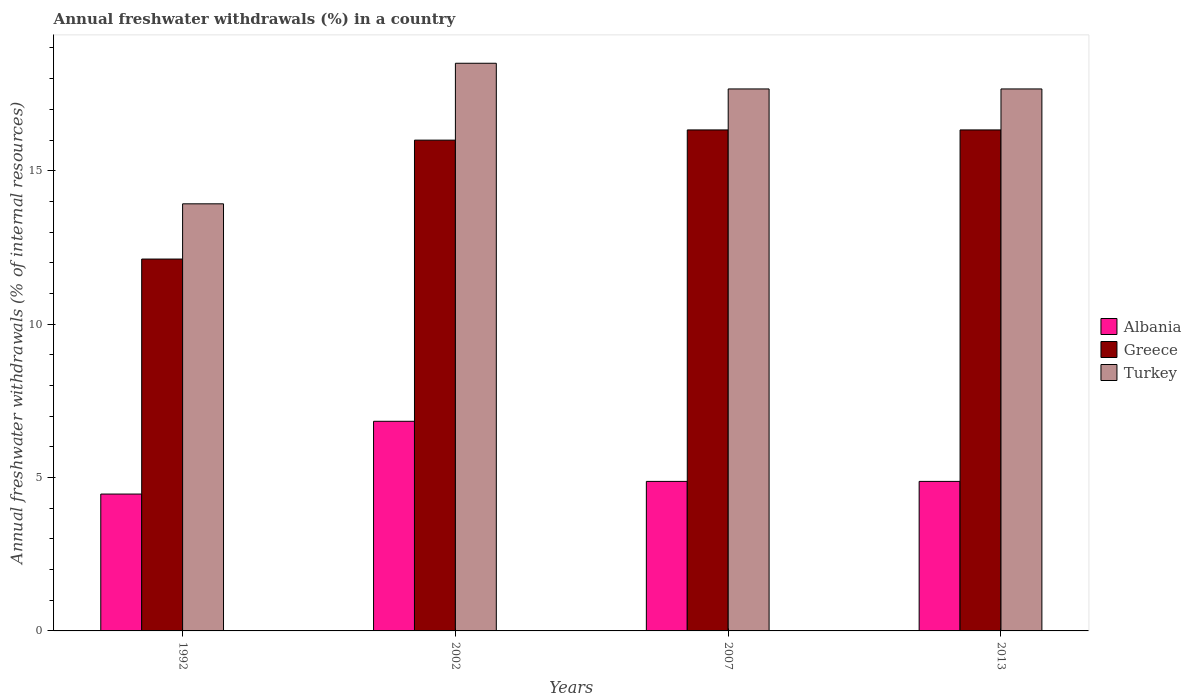How many different coloured bars are there?
Your response must be concise. 3. Are the number of bars per tick equal to the number of legend labels?
Your answer should be very brief. Yes. Are the number of bars on each tick of the X-axis equal?
Provide a succinct answer. Yes. How many bars are there on the 2nd tick from the right?
Offer a terse response. 3. What is the label of the 4th group of bars from the left?
Your response must be concise. 2013. In how many cases, is the number of bars for a given year not equal to the number of legend labels?
Give a very brief answer. 0. What is the percentage of annual freshwater withdrawals in Greece in 2002?
Keep it short and to the point. 16. Across all years, what is the maximum percentage of annual freshwater withdrawals in Albania?
Ensure brevity in your answer.  6.83. Across all years, what is the minimum percentage of annual freshwater withdrawals in Greece?
Give a very brief answer. 12.12. In which year was the percentage of annual freshwater withdrawals in Turkey maximum?
Your answer should be very brief. 2002. What is the total percentage of annual freshwater withdrawals in Greece in the graph?
Ensure brevity in your answer.  60.78. What is the difference between the percentage of annual freshwater withdrawals in Albania in 2002 and that in 2013?
Your answer should be compact. 1.96. What is the difference between the percentage of annual freshwater withdrawals in Albania in 2007 and the percentage of annual freshwater withdrawals in Greece in 2002?
Ensure brevity in your answer.  -11.12. What is the average percentage of annual freshwater withdrawals in Albania per year?
Give a very brief answer. 5.26. In the year 1992, what is the difference between the percentage of annual freshwater withdrawals in Greece and percentage of annual freshwater withdrawals in Turkey?
Offer a very short reply. -1.8. In how many years, is the percentage of annual freshwater withdrawals in Albania greater than 7 %?
Ensure brevity in your answer.  0. What is the ratio of the percentage of annual freshwater withdrawals in Albania in 1992 to that in 2007?
Provide a short and direct response. 0.92. Is the percentage of annual freshwater withdrawals in Turkey in 2007 less than that in 2013?
Your answer should be very brief. No. Is the difference between the percentage of annual freshwater withdrawals in Greece in 1992 and 2013 greater than the difference between the percentage of annual freshwater withdrawals in Turkey in 1992 and 2013?
Your answer should be very brief. No. What is the difference between the highest and the second highest percentage of annual freshwater withdrawals in Albania?
Your answer should be very brief. 1.96. What is the difference between the highest and the lowest percentage of annual freshwater withdrawals in Turkey?
Your answer should be very brief. 4.58. Is the sum of the percentage of annual freshwater withdrawals in Turkey in 1992 and 2002 greater than the maximum percentage of annual freshwater withdrawals in Albania across all years?
Your answer should be compact. Yes. What does the 1st bar from the left in 2002 represents?
Your response must be concise. Albania. What does the 2nd bar from the right in 1992 represents?
Keep it short and to the point. Greece. Is it the case that in every year, the sum of the percentage of annual freshwater withdrawals in Albania and percentage of annual freshwater withdrawals in Greece is greater than the percentage of annual freshwater withdrawals in Turkey?
Provide a succinct answer. Yes. What is the difference between two consecutive major ticks on the Y-axis?
Your response must be concise. 5. Are the values on the major ticks of Y-axis written in scientific E-notation?
Offer a very short reply. No. How many legend labels are there?
Provide a succinct answer. 3. What is the title of the graph?
Provide a short and direct response. Annual freshwater withdrawals (%) in a country. What is the label or title of the Y-axis?
Provide a short and direct response. Annual freshwater withdrawals (% of internal resources). What is the Annual freshwater withdrawals (% of internal resources) in Albania in 1992?
Offer a very short reply. 4.46. What is the Annual freshwater withdrawals (% of internal resources) in Greece in 1992?
Ensure brevity in your answer.  12.12. What is the Annual freshwater withdrawals (% of internal resources) in Turkey in 1992?
Ensure brevity in your answer.  13.92. What is the Annual freshwater withdrawals (% of internal resources) of Albania in 2002?
Your answer should be compact. 6.83. What is the Annual freshwater withdrawals (% of internal resources) in Greece in 2002?
Your answer should be very brief. 16. What is the Annual freshwater withdrawals (% of internal resources) of Turkey in 2002?
Give a very brief answer. 18.5. What is the Annual freshwater withdrawals (% of internal resources) in Albania in 2007?
Offer a terse response. 4.87. What is the Annual freshwater withdrawals (% of internal resources) in Greece in 2007?
Provide a short and direct response. 16.33. What is the Annual freshwater withdrawals (% of internal resources) of Turkey in 2007?
Keep it short and to the point. 17.67. What is the Annual freshwater withdrawals (% of internal resources) in Albania in 2013?
Provide a short and direct response. 4.87. What is the Annual freshwater withdrawals (% of internal resources) in Greece in 2013?
Keep it short and to the point. 16.33. What is the Annual freshwater withdrawals (% of internal resources) in Turkey in 2013?
Give a very brief answer. 17.67. Across all years, what is the maximum Annual freshwater withdrawals (% of internal resources) of Albania?
Ensure brevity in your answer.  6.83. Across all years, what is the maximum Annual freshwater withdrawals (% of internal resources) of Greece?
Your answer should be compact. 16.33. Across all years, what is the maximum Annual freshwater withdrawals (% of internal resources) of Turkey?
Offer a terse response. 18.5. Across all years, what is the minimum Annual freshwater withdrawals (% of internal resources) of Albania?
Your answer should be compact. 4.46. Across all years, what is the minimum Annual freshwater withdrawals (% of internal resources) of Greece?
Provide a short and direct response. 12.12. Across all years, what is the minimum Annual freshwater withdrawals (% of internal resources) of Turkey?
Your response must be concise. 13.92. What is the total Annual freshwater withdrawals (% of internal resources) in Albania in the graph?
Provide a short and direct response. 21.04. What is the total Annual freshwater withdrawals (% of internal resources) in Greece in the graph?
Ensure brevity in your answer.  60.78. What is the total Annual freshwater withdrawals (% of internal resources) in Turkey in the graph?
Ensure brevity in your answer.  67.75. What is the difference between the Annual freshwater withdrawals (% of internal resources) in Albania in 1992 and that in 2002?
Offer a terse response. -2.37. What is the difference between the Annual freshwater withdrawals (% of internal resources) of Greece in 1992 and that in 2002?
Make the answer very short. -3.88. What is the difference between the Annual freshwater withdrawals (% of internal resources) in Turkey in 1992 and that in 2002?
Provide a succinct answer. -4.58. What is the difference between the Annual freshwater withdrawals (% of internal resources) of Albania in 1992 and that in 2007?
Make the answer very short. -0.41. What is the difference between the Annual freshwater withdrawals (% of internal resources) of Greece in 1992 and that in 2007?
Give a very brief answer. -4.21. What is the difference between the Annual freshwater withdrawals (% of internal resources) in Turkey in 1992 and that in 2007?
Your response must be concise. -3.74. What is the difference between the Annual freshwater withdrawals (% of internal resources) in Albania in 1992 and that in 2013?
Make the answer very short. -0.41. What is the difference between the Annual freshwater withdrawals (% of internal resources) in Greece in 1992 and that in 2013?
Offer a terse response. -4.21. What is the difference between the Annual freshwater withdrawals (% of internal resources) of Turkey in 1992 and that in 2013?
Keep it short and to the point. -3.74. What is the difference between the Annual freshwater withdrawals (% of internal resources) in Albania in 2002 and that in 2007?
Ensure brevity in your answer.  1.96. What is the difference between the Annual freshwater withdrawals (% of internal resources) of Greece in 2002 and that in 2007?
Provide a succinct answer. -0.33. What is the difference between the Annual freshwater withdrawals (% of internal resources) of Turkey in 2002 and that in 2007?
Your response must be concise. 0.84. What is the difference between the Annual freshwater withdrawals (% of internal resources) in Albania in 2002 and that in 2013?
Offer a terse response. 1.96. What is the difference between the Annual freshwater withdrawals (% of internal resources) in Greece in 2002 and that in 2013?
Your answer should be very brief. -0.33. What is the difference between the Annual freshwater withdrawals (% of internal resources) in Turkey in 2002 and that in 2013?
Ensure brevity in your answer.  0.84. What is the difference between the Annual freshwater withdrawals (% of internal resources) of Greece in 2007 and that in 2013?
Your answer should be very brief. 0. What is the difference between the Annual freshwater withdrawals (% of internal resources) of Albania in 1992 and the Annual freshwater withdrawals (% of internal resources) of Greece in 2002?
Your response must be concise. -11.54. What is the difference between the Annual freshwater withdrawals (% of internal resources) of Albania in 1992 and the Annual freshwater withdrawals (% of internal resources) of Turkey in 2002?
Your answer should be compact. -14.04. What is the difference between the Annual freshwater withdrawals (% of internal resources) in Greece in 1992 and the Annual freshwater withdrawals (% of internal resources) in Turkey in 2002?
Keep it short and to the point. -6.38. What is the difference between the Annual freshwater withdrawals (% of internal resources) in Albania in 1992 and the Annual freshwater withdrawals (% of internal resources) in Greece in 2007?
Offer a terse response. -11.87. What is the difference between the Annual freshwater withdrawals (% of internal resources) in Albania in 1992 and the Annual freshwater withdrawals (% of internal resources) in Turkey in 2007?
Make the answer very short. -13.2. What is the difference between the Annual freshwater withdrawals (% of internal resources) of Greece in 1992 and the Annual freshwater withdrawals (% of internal resources) of Turkey in 2007?
Your response must be concise. -5.54. What is the difference between the Annual freshwater withdrawals (% of internal resources) of Albania in 1992 and the Annual freshwater withdrawals (% of internal resources) of Greece in 2013?
Provide a succinct answer. -11.87. What is the difference between the Annual freshwater withdrawals (% of internal resources) in Albania in 1992 and the Annual freshwater withdrawals (% of internal resources) in Turkey in 2013?
Give a very brief answer. -13.2. What is the difference between the Annual freshwater withdrawals (% of internal resources) in Greece in 1992 and the Annual freshwater withdrawals (% of internal resources) in Turkey in 2013?
Your answer should be very brief. -5.54. What is the difference between the Annual freshwater withdrawals (% of internal resources) in Albania in 2002 and the Annual freshwater withdrawals (% of internal resources) in Greece in 2007?
Give a very brief answer. -9.5. What is the difference between the Annual freshwater withdrawals (% of internal resources) in Albania in 2002 and the Annual freshwater withdrawals (% of internal resources) in Turkey in 2007?
Your answer should be very brief. -10.83. What is the difference between the Annual freshwater withdrawals (% of internal resources) of Greece in 2002 and the Annual freshwater withdrawals (% of internal resources) of Turkey in 2007?
Ensure brevity in your answer.  -1.67. What is the difference between the Annual freshwater withdrawals (% of internal resources) in Albania in 2002 and the Annual freshwater withdrawals (% of internal resources) in Greece in 2013?
Give a very brief answer. -9.5. What is the difference between the Annual freshwater withdrawals (% of internal resources) in Albania in 2002 and the Annual freshwater withdrawals (% of internal resources) in Turkey in 2013?
Keep it short and to the point. -10.83. What is the difference between the Annual freshwater withdrawals (% of internal resources) of Greece in 2002 and the Annual freshwater withdrawals (% of internal resources) of Turkey in 2013?
Make the answer very short. -1.67. What is the difference between the Annual freshwater withdrawals (% of internal resources) of Albania in 2007 and the Annual freshwater withdrawals (% of internal resources) of Greece in 2013?
Your response must be concise. -11.46. What is the difference between the Annual freshwater withdrawals (% of internal resources) in Albania in 2007 and the Annual freshwater withdrawals (% of internal resources) in Turkey in 2013?
Your answer should be very brief. -12.79. What is the difference between the Annual freshwater withdrawals (% of internal resources) of Greece in 2007 and the Annual freshwater withdrawals (% of internal resources) of Turkey in 2013?
Your answer should be very brief. -1.34. What is the average Annual freshwater withdrawals (% of internal resources) in Albania per year?
Give a very brief answer. 5.26. What is the average Annual freshwater withdrawals (% of internal resources) of Greece per year?
Your answer should be compact. 15.19. What is the average Annual freshwater withdrawals (% of internal resources) in Turkey per year?
Ensure brevity in your answer.  16.94. In the year 1992, what is the difference between the Annual freshwater withdrawals (% of internal resources) in Albania and Annual freshwater withdrawals (% of internal resources) in Greece?
Ensure brevity in your answer.  -7.66. In the year 1992, what is the difference between the Annual freshwater withdrawals (% of internal resources) in Albania and Annual freshwater withdrawals (% of internal resources) in Turkey?
Ensure brevity in your answer.  -9.46. In the year 2002, what is the difference between the Annual freshwater withdrawals (% of internal resources) in Albania and Annual freshwater withdrawals (% of internal resources) in Greece?
Your answer should be very brief. -9.16. In the year 2002, what is the difference between the Annual freshwater withdrawals (% of internal resources) in Albania and Annual freshwater withdrawals (% of internal resources) in Turkey?
Give a very brief answer. -11.67. In the year 2002, what is the difference between the Annual freshwater withdrawals (% of internal resources) of Greece and Annual freshwater withdrawals (% of internal resources) of Turkey?
Your answer should be compact. -2.51. In the year 2007, what is the difference between the Annual freshwater withdrawals (% of internal resources) in Albania and Annual freshwater withdrawals (% of internal resources) in Greece?
Your response must be concise. -11.46. In the year 2007, what is the difference between the Annual freshwater withdrawals (% of internal resources) in Albania and Annual freshwater withdrawals (% of internal resources) in Turkey?
Your answer should be compact. -12.79. In the year 2007, what is the difference between the Annual freshwater withdrawals (% of internal resources) of Greece and Annual freshwater withdrawals (% of internal resources) of Turkey?
Provide a succinct answer. -1.34. In the year 2013, what is the difference between the Annual freshwater withdrawals (% of internal resources) of Albania and Annual freshwater withdrawals (% of internal resources) of Greece?
Keep it short and to the point. -11.46. In the year 2013, what is the difference between the Annual freshwater withdrawals (% of internal resources) of Albania and Annual freshwater withdrawals (% of internal resources) of Turkey?
Give a very brief answer. -12.79. In the year 2013, what is the difference between the Annual freshwater withdrawals (% of internal resources) in Greece and Annual freshwater withdrawals (% of internal resources) in Turkey?
Ensure brevity in your answer.  -1.34. What is the ratio of the Annual freshwater withdrawals (% of internal resources) in Albania in 1992 to that in 2002?
Your response must be concise. 0.65. What is the ratio of the Annual freshwater withdrawals (% of internal resources) in Greece in 1992 to that in 2002?
Give a very brief answer. 0.76. What is the ratio of the Annual freshwater withdrawals (% of internal resources) in Turkey in 1992 to that in 2002?
Make the answer very short. 0.75. What is the ratio of the Annual freshwater withdrawals (% of internal resources) of Albania in 1992 to that in 2007?
Your answer should be compact. 0.92. What is the ratio of the Annual freshwater withdrawals (% of internal resources) of Greece in 1992 to that in 2007?
Ensure brevity in your answer.  0.74. What is the ratio of the Annual freshwater withdrawals (% of internal resources) of Turkey in 1992 to that in 2007?
Offer a very short reply. 0.79. What is the ratio of the Annual freshwater withdrawals (% of internal resources) in Albania in 1992 to that in 2013?
Your answer should be very brief. 0.92. What is the ratio of the Annual freshwater withdrawals (% of internal resources) of Greece in 1992 to that in 2013?
Provide a short and direct response. 0.74. What is the ratio of the Annual freshwater withdrawals (% of internal resources) in Turkey in 1992 to that in 2013?
Offer a terse response. 0.79. What is the ratio of the Annual freshwater withdrawals (% of internal resources) of Albania in 2002 to that in 2007?
Your answer should be compact. 1.4. What is the ratio of the Annual freshwater withdrawals (% of internal resources) in Greece in 2002 to that in 2007?
Your answer should be compact. 0.98. What is the ratio of the Annual freshwater withdrawals (% of internal resources) of Turkey in 2002 to that in 2007?
Your answer should be very brief. 1.05. What is the ratio of the Annual freshwater withdrawals (% of internal resources) in Albania in 2002 to that in 2013?
Your response must be concise. 1.4. What is the ratio of the Annual freshwater withdrawals (% of internal resources) of Greece in 2002 to that in 2013?
Provide a succinct answer. 0.98. What is the ratio of the Annual freshwater withdrawals (% of internal resources) in Turkey in 2002 to that in 2013?
Provide a short and direct response. 1.05. What is the ratio of the Annual freshwater withdrawals (% of internal resources) in Greece in 2007 to that in 2013?
Ensure brevity in your answer.  1. What is the ratio of the Annual freshwater withdrawals (% of internal resources) in Turkey in 2007 to that in 2013?
Your response must be concise. 1. What is the difference between the highest and the second highest Annual freshwater withdrawals (% of internal resources) in Albania?
Make the answer very short. 1.96. What is the difference between the highest and the second highest Annual freshwater withdrawals (% of internal resources) in Greece?
Keep it short and to the point. 0. What is the difference between the highest and the second highest Annual freshwater withdrawals (% of internal resources) of Turkey?
Provide a succinct answer. 0.84. What is the difference between the highest and the lowest Annual freshwater withdrawals (% of internal resources) of Albania?
Provide a succinct answer. 2.37. What is the difference between the highest and the lowest Annual freshwater withdrawals (% of internal resources) of Greece?
Offer a terse response. 4.21. What is the difference between the highest and the lowest Annual freshwater withdrawals (% of internal resources) in Turkey?
Your answer should be very brief. 4.58. 